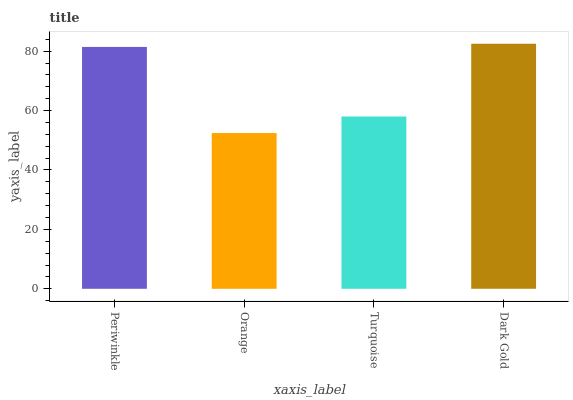Is Orange the minimum?
Answer yes or no. Yes. Is Dark Gold the maximum?
Answer yes or no. Yes. Is Turquoise the minimum?
Answer yes or no. No. Is Turquoise the maximum?
Answer yes or no. No. Is Turquoise greater than Orange?
Answer yes or no. Yes. Is Orange less than Turquoise?
Answer yes or no. Yes. Is Orange greater than Turquoise?
Answer yes or no. No. Is Turquoise less than Orange?
Answer yes or no. No. Is Periwinkle the high median?
Answer yes or no. Yes. Is Turquoise the low median?
Answer yes or no. Yes. Is Dark Gold the high median?
Answer yes or no. No. Is Orange the low median?
Answer yes or no. No. 